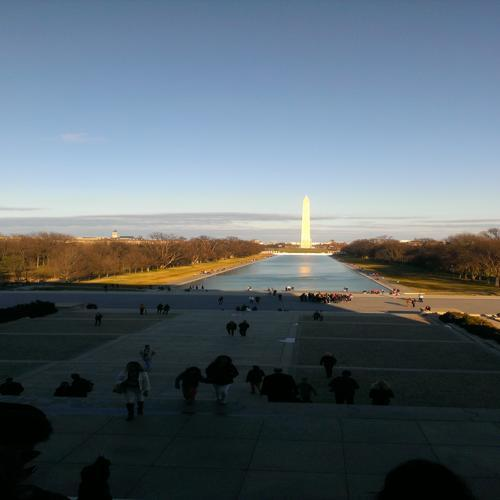What is the main issue in the structure of the figure?
A. horizontal stretching and distortion
B. clear structure
C. vertical compression
D. no issue
Answer with the option's letter from the given choices directly.
 A. 